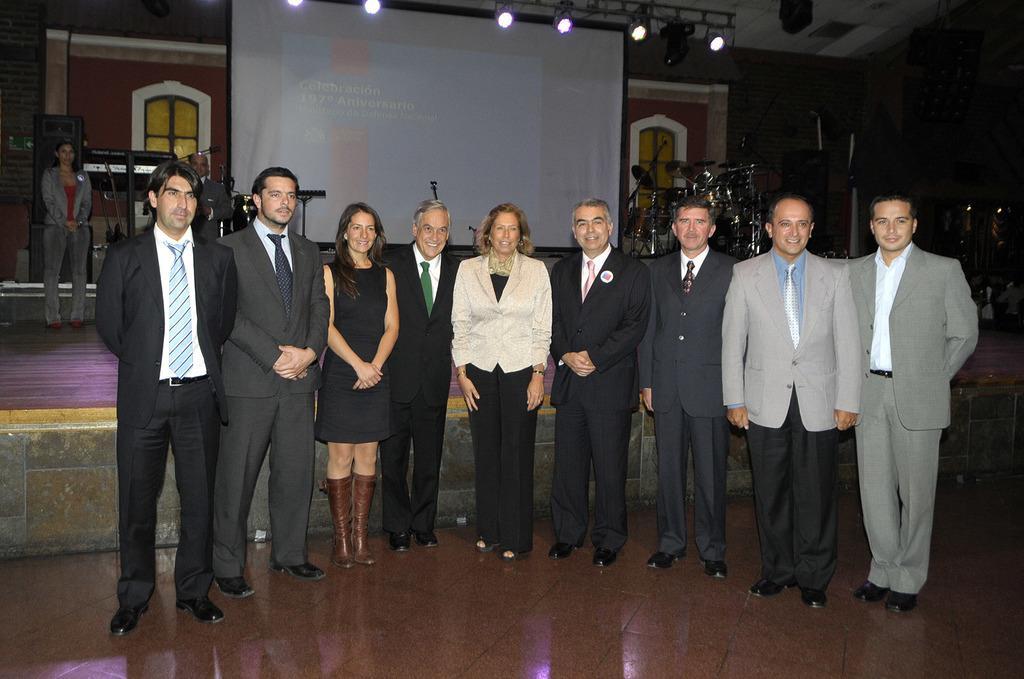Describe this image in one or two sentences. In this picture there are people standing on the floor. In the background we can see people, musical instruments, lights, screen, stage, windows, wall and objects. 